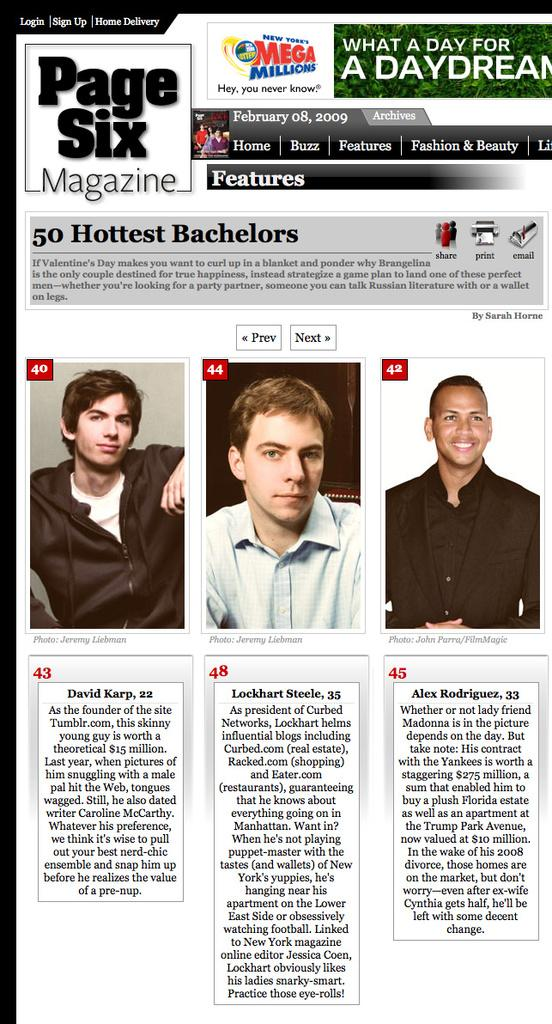What type of material is present in the image? There is a magazine paper in the image. How many people are in the image? There are three persons in the image. What can be seen on the magazine paper? There is text visible in the image. What brand or company might be associated with the image? There is a logo in the image, which could be associated with a brand or company. What design elements are present on the magazine paper? There are title boxes in the image. What type of weather can be seen in the image? There is no weather or natural phenomena visible in the image; it features a magazine with text, a logo, and title boxes. 